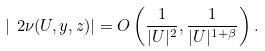Convert formula to latex. <formula><loc_0><loc_0><loc_500><loc_500>| \ 2 \nu ( U , y , z ) | = O \left ( \frac { 1 } { | U | ^ { 2 } } , \frac { 1 } { | U | ^ { 1 + \beta } } \right ) .</formula> 